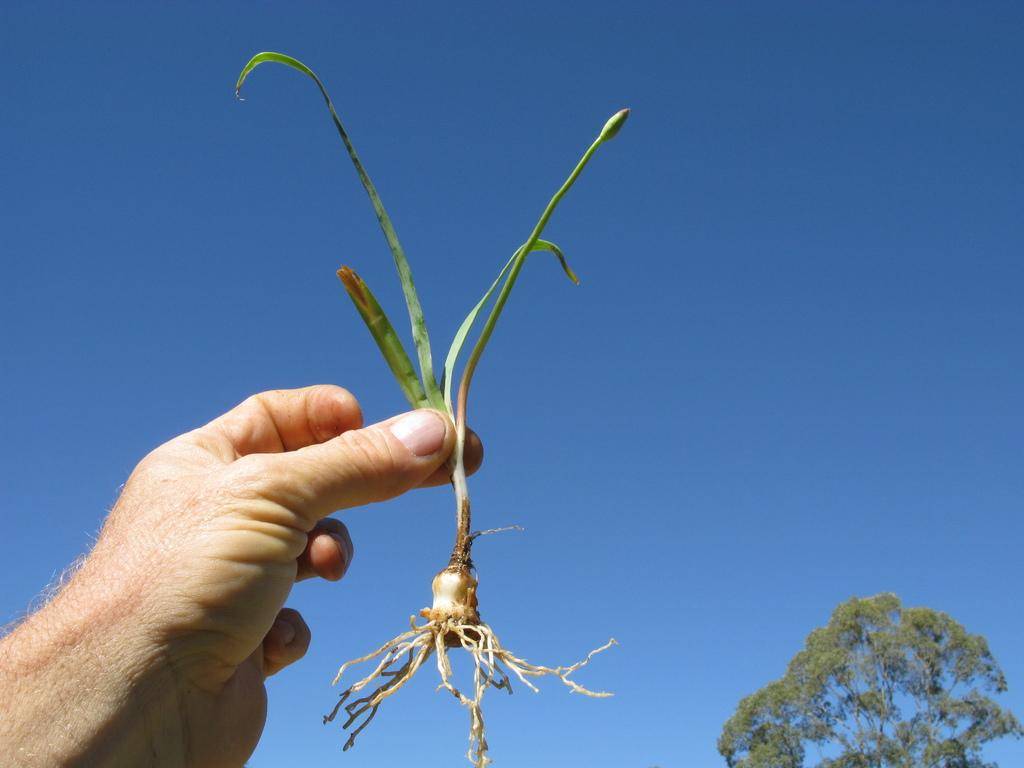What is the person in the image holding? There is a hand holding a plant in the image. What can be seen in the background of the image? There is a tree and the sky visible in the background of the image. What type of quartz can be seen on the person's desk in the image? There is no quartz or desk present in the image; it features a hand holding a plant and a background with a tree and the sky. 